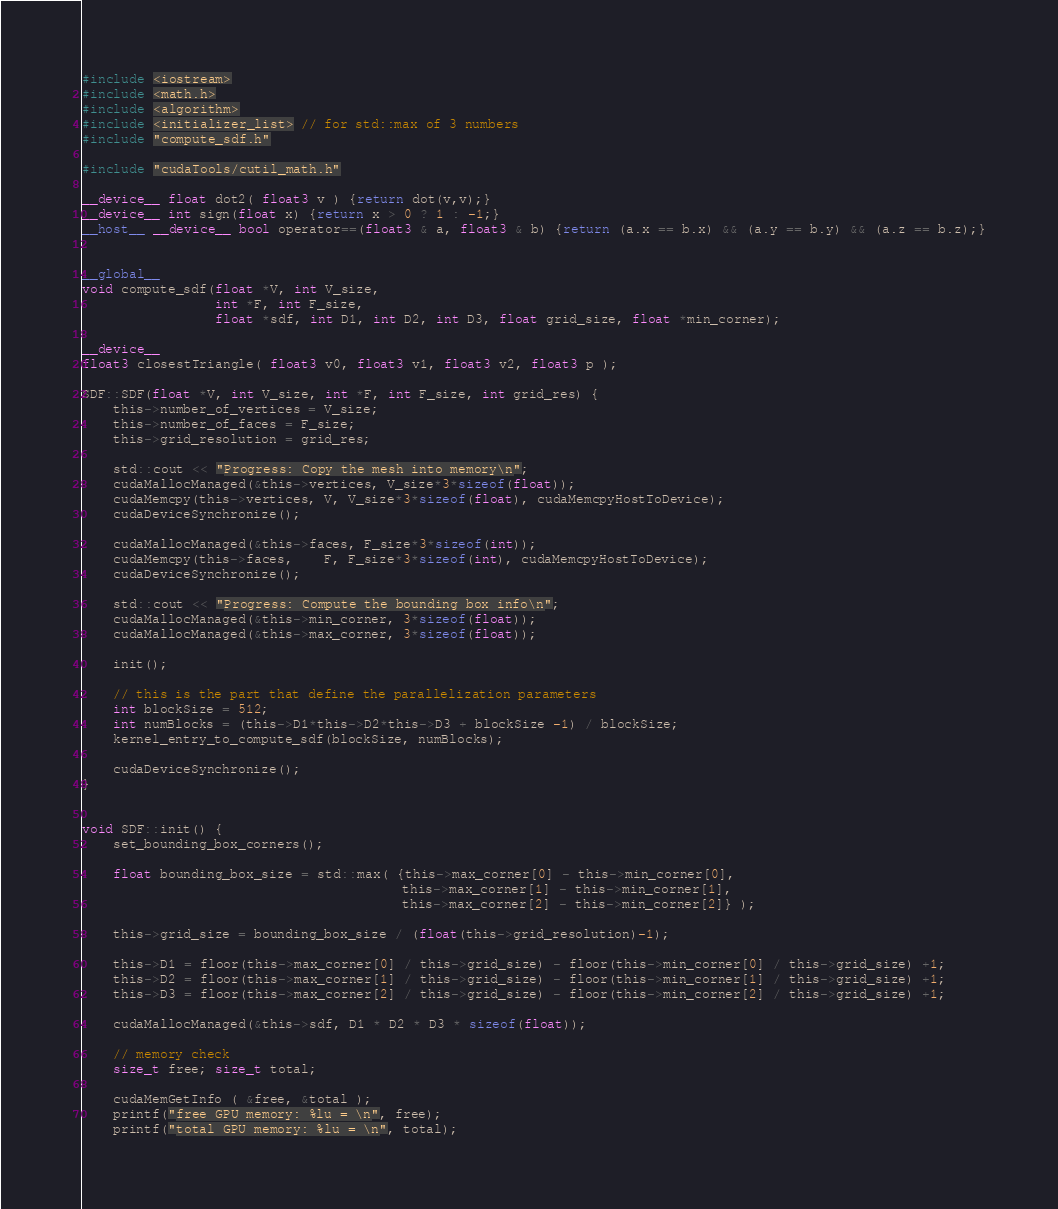<code> <loc_0><loc_0><loc_500><loc_500><_Cuda_>#include <iostream>
#include <math.h>
#include <algorithm>
#include <initializer_list> // for std::max of 3 numbers
#include "compute_sdf.h"

#include "cudaTools/cutil_math.h"

__device__ float dot2( float3 v ) {return dot(v,v);}
__device__ int sign(float x) {return x > 0 ? 1 : -1;}
__host__ __device__ bool operator==(float3 & a, float3 & b) {return (a.x == b.x) && (a.y == b.y) && (a.z == b.z);}


__global__
void compute_sdf(float *V, int V_size, 
                 int *F, int F_size,
                 float *sdf, int D1, int D2, int D3, float grid_size, float *min_corner);

__device__
float3 closestTriangle( float3 v0, float3 v1, float3 v2, float3 p );

SDF::SDF(float *V, int V_size, int *F, int F_size, int grid_res) {
    this->number_of_vertices = V_size;
    this->number_of_faces = F_size;
    this->grid_resolution = grid_res;

    std::cout << "Progress: Copy the mesh into memory\n";
    cudaMallocManaged(&this->vertices, V_size*3*sizeof(float));
    cudaMemcpy(this->vertices, V, V_size*3*sizeof(float), cudaMemcpyHostToDevice);
    cudaDeviceSynchronize();

    cudaMallocManaged(&this->faces, F_size*3*sizeof(int));
    cudaMemcpy(this->faces,    F, F_size*3*sizeof(int), cudaMemcpyHostToDevice);
    cudaDeviceSynchronize();

    std::cout << "Progress: Compute the bounding box info\n";
    cudaMallocManaged(&this->min_corner, 3*sizeof(float));
    cudaMallocManaged(&this->max_corner, 3*sizeof(float));

    init();

    // this is the part that define the parallelization parameters
    int blockSize = 512;
    int numBlocks = (this->D1*this->D2*this->D3 + blockSize -1) / blockSize;
    kernel_entry_to_compute_sdf(blockSize, numBlocks);
    
    cudaDeviceSynchronize();
}


void SDF::init() {
    set_bounding_box_corners();

    float bounding_box_size = std::max( {this->max_corner[0] - this->min_corner[0], 
                                         this->max_corner[1] - this->min_corner[1], 
                                         this->max_corner[2] - this->min_corner[2]} );
    
    this->grid_size = bounding_box_size / (float(this->grid_resolution)-1);

    this->D1 = floor(this->max_corner[0] / this->grid_size) - floor(this->min_corner[0] / this->grid_size) +1;
    this->D2 = floor(this->max_corner[1] / this->grid_size) - floor(this->min_corner[1] / this->grid_size) +1;
    this->D3 = floor(this->max_corner[2] / this->grid_size) - floor(this->min_corner[2] / this->grid_size) +1;

    cudaMallocManaged(&this->sdf, D1 * D2 * D3 * sizeof(float));

    // memory check
    size_t free; size_t total;
    
    cudaMemGetInfo ( &free, &total );
    printf("free GPU memory: %lu = \n", free);
    printf("total GPU memory: %lu = \n", total);</code> 